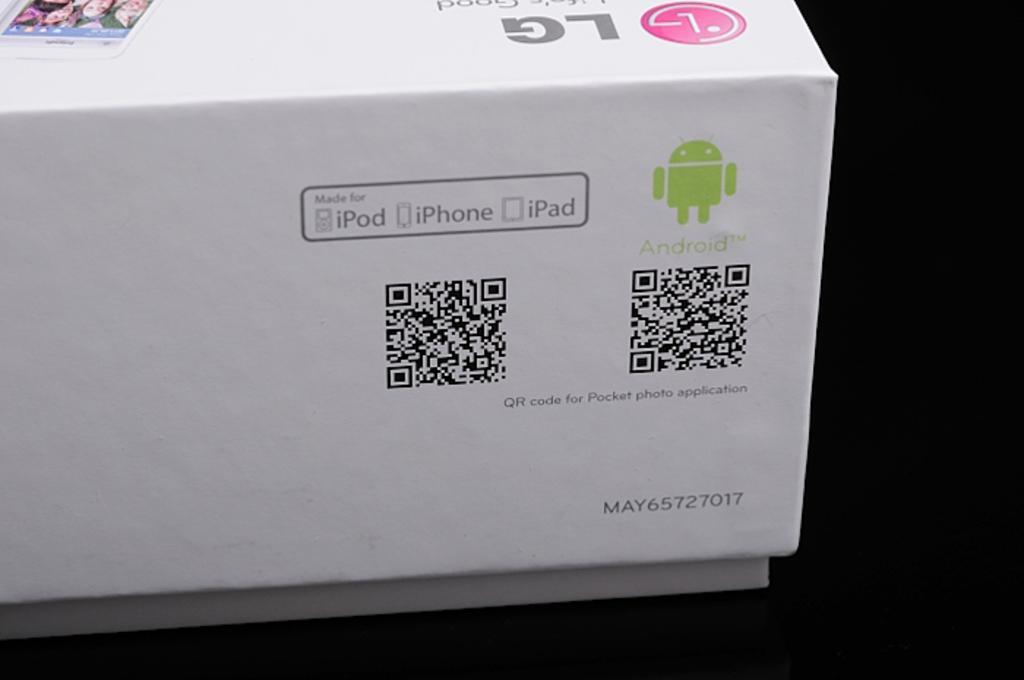<image>
Describe the image concisely. Whatever is contained in this box is made for iPod iPhone and iPad. 